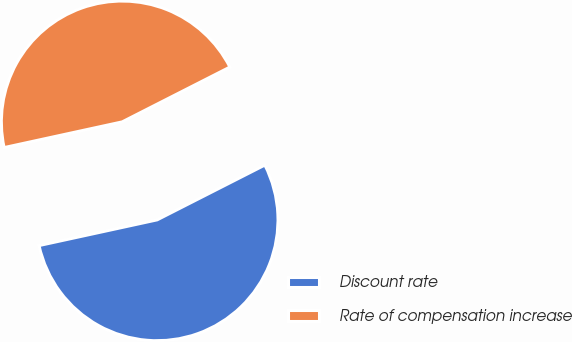Convert chart. <chart><loc_0><loc_0><loc_500><loc_500><pie_chart><fcel>Discount rate<fcel>Rate of compensation increase<nl><fcel>54.08%<fcel>45.92%<nl></chart> 